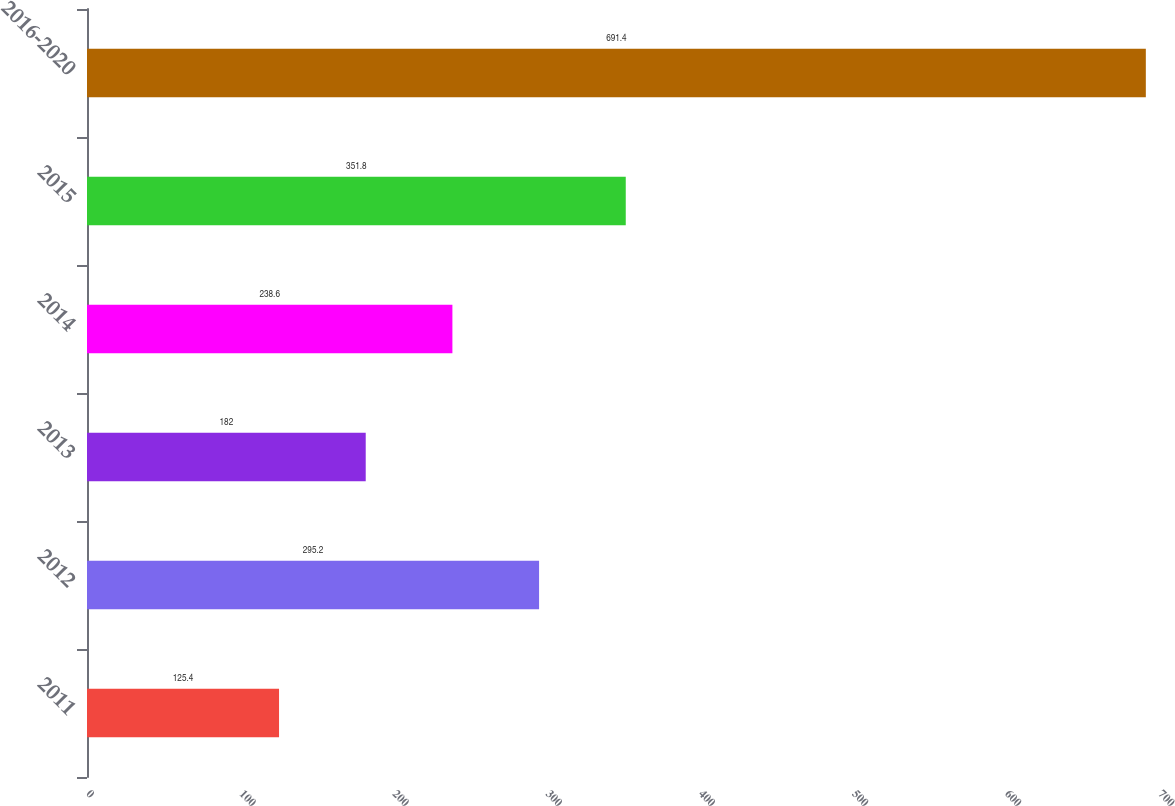<chart> <loc_0><loc_0><loc_500><loc_500><bar_chart><fcel>2011<fcel>2012<fcel>2013<fcel>2014<fcel>2015<fcel>2016-2020<nl><fcel>125.4<fcel>295.2<fcel>182<fcel>238.6<fcel>351.8<fcel>691.4<nl></chart> 